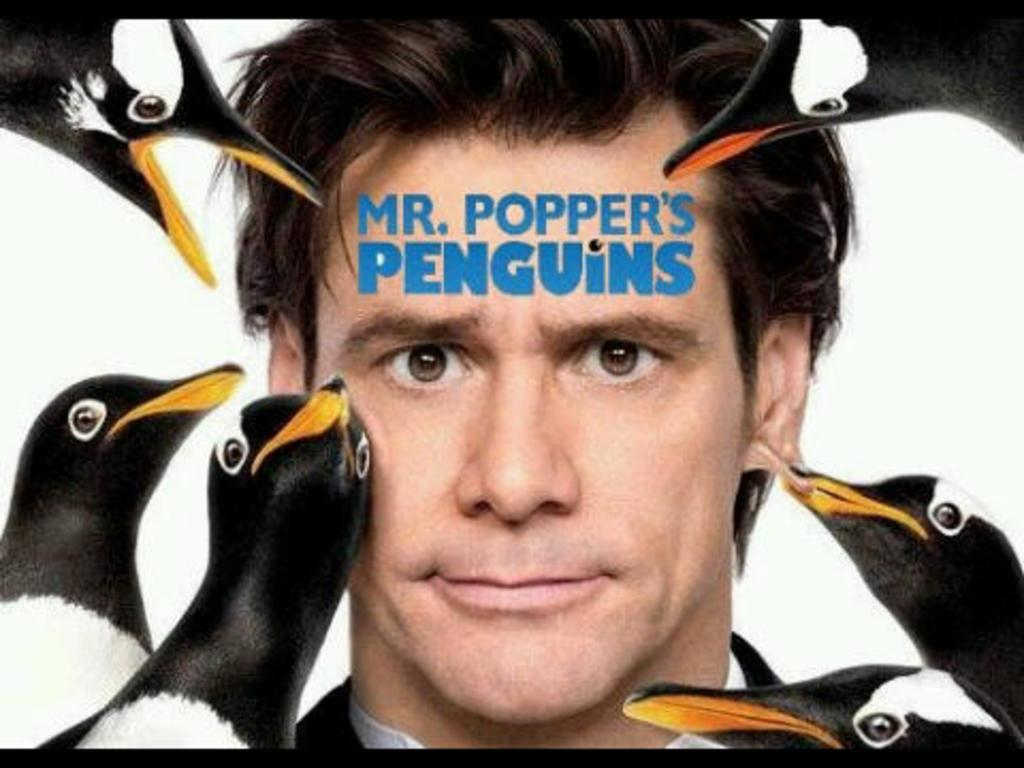Who or what is the main subject in the image? There is a man in the image. What is unique about the man's appearance in the image? There are birds' heads around the man's face. Is there any text or label associated with the man in the image? Yes, there is a name on the man's head. What type of stone is being divided by the man in the image? There is no stone present in the image, nor is the man dividing anything. 